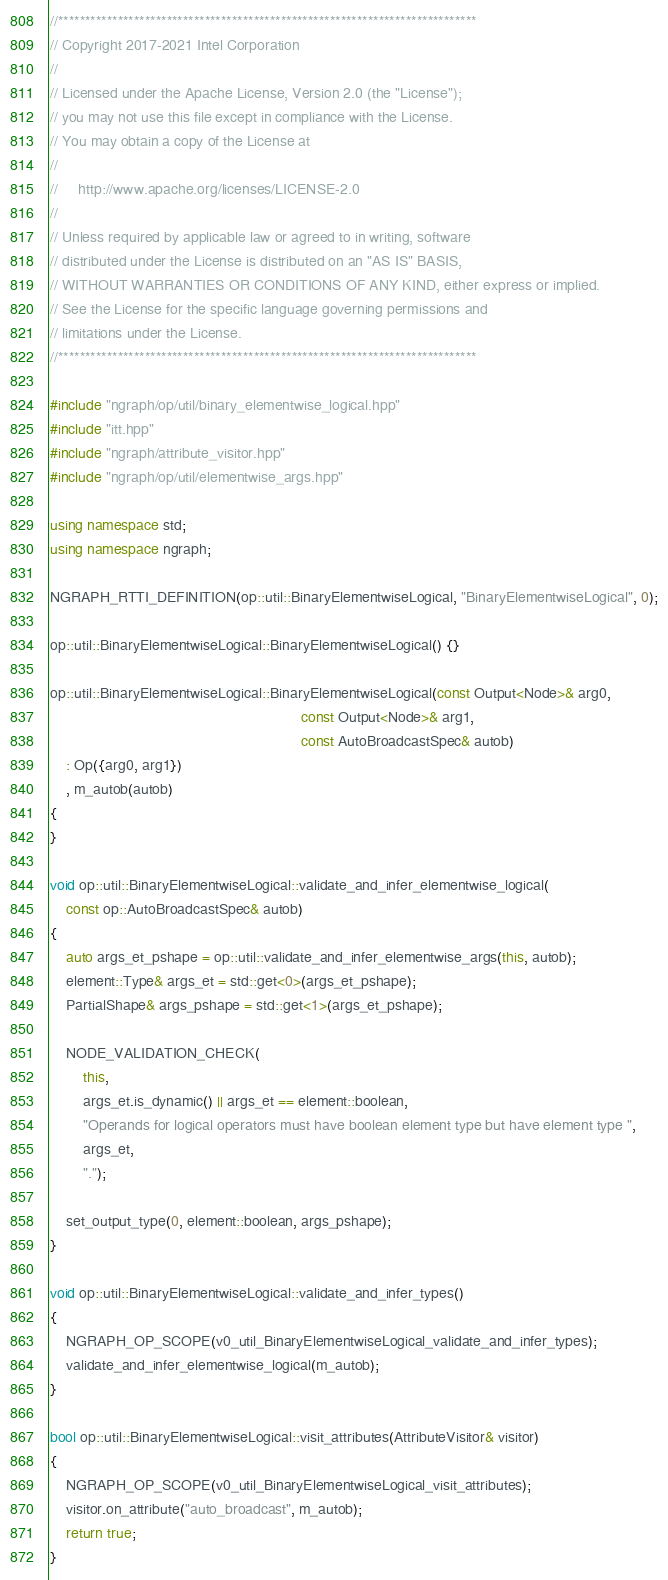Convert code to text. <code><loc_0><loc_0><loc_500><loc_500><_C++_>//*****************************************************************************
// Copyright 2017-2021 Intel Corporation
//
// Licensed under the Apache License, Version 2.0 (the "License");
// you may not use this file except in compliance with the License.
// You may obtain a copy of the License at
//
//     http://www.apache.org/licenses/LICENSE-2.0
//
// Unless required by applicable law or agreed to in writing, software
// distributed under the License is distributed on an "AS IS" BASIS,
// WITHOUT WARRANTIES OR CONDITIONS OF ANY KIND, either express or implied.
// See the License for the specific language governing permissions and
// limitations under the License.
//*****************************************************************************

#include "ngraph/op/util/binary_elementwise_logical.hpp"
#include "itt.hpp"
#include "ngraph/attribute_visitor.hpp"
#include "ngraph/op/util/elementwise_args.hpp"

using namespace std;
using namespace ngraph;

NGRAPH_RTTI_DEFINITION(op::util::BinaryElementwiseLogical, "BinaryElementwiseLogical", 0);

op::util::BinaryElementwiseLogical::BinaryElementwiseLogical() {}

op::util::BinaryElementwiseLogical::BinaryElementwiseLogical(const Output<Node>& arg0,
                                                             const Output<Node>& arg1,
                                                             const AutoBroadcastSpec& autob)
    : Op({arg0, arg1})
    , m_autob(autob)
{
}

void op::util::BinaryElementwiseLogical::validate_and_infer_elementwise_logical(
    const op::AutoBroadcastSpec& autob)
{
    auto args_et_pshape = op::util::validate_and_infer_elementwise_args(this, autob);
    element::Type& args_et = std::get<0>(args_et_pshape);
    PartialShape& args_pshape = std::get<1>(args_et_pshape);

    NODE_VALIDATION_CHECK(
        this,
        args_et.is_dynamic() || args_et == element::boolean,
        "Operands for logical operators must have boolean element type but have element type ",
        args_et,
        ".");

    set_output_type(0, element::boolean, args_pshape);
}

void op::util::BinaryElementwiseLogical::validate_and_infer_types()
{
    NGRAPH_OP_SCOPE(v0_util_BinaryElementwiseLogical_validate_and_infer_types);
    validate_and_infer_elementwise_logical(m_autob);
}

bool op::util::BinaryElementwiseLogical::visit_attributes(AttributeVisitor& visitor)
{
    NGRAPH_OP_SCOPE(v0_util_BinaryElementwiseLogical_visit_attributes);
    visitor.on_attribute("auto_broadcast", m_autob);
    return true;
}
</code> 